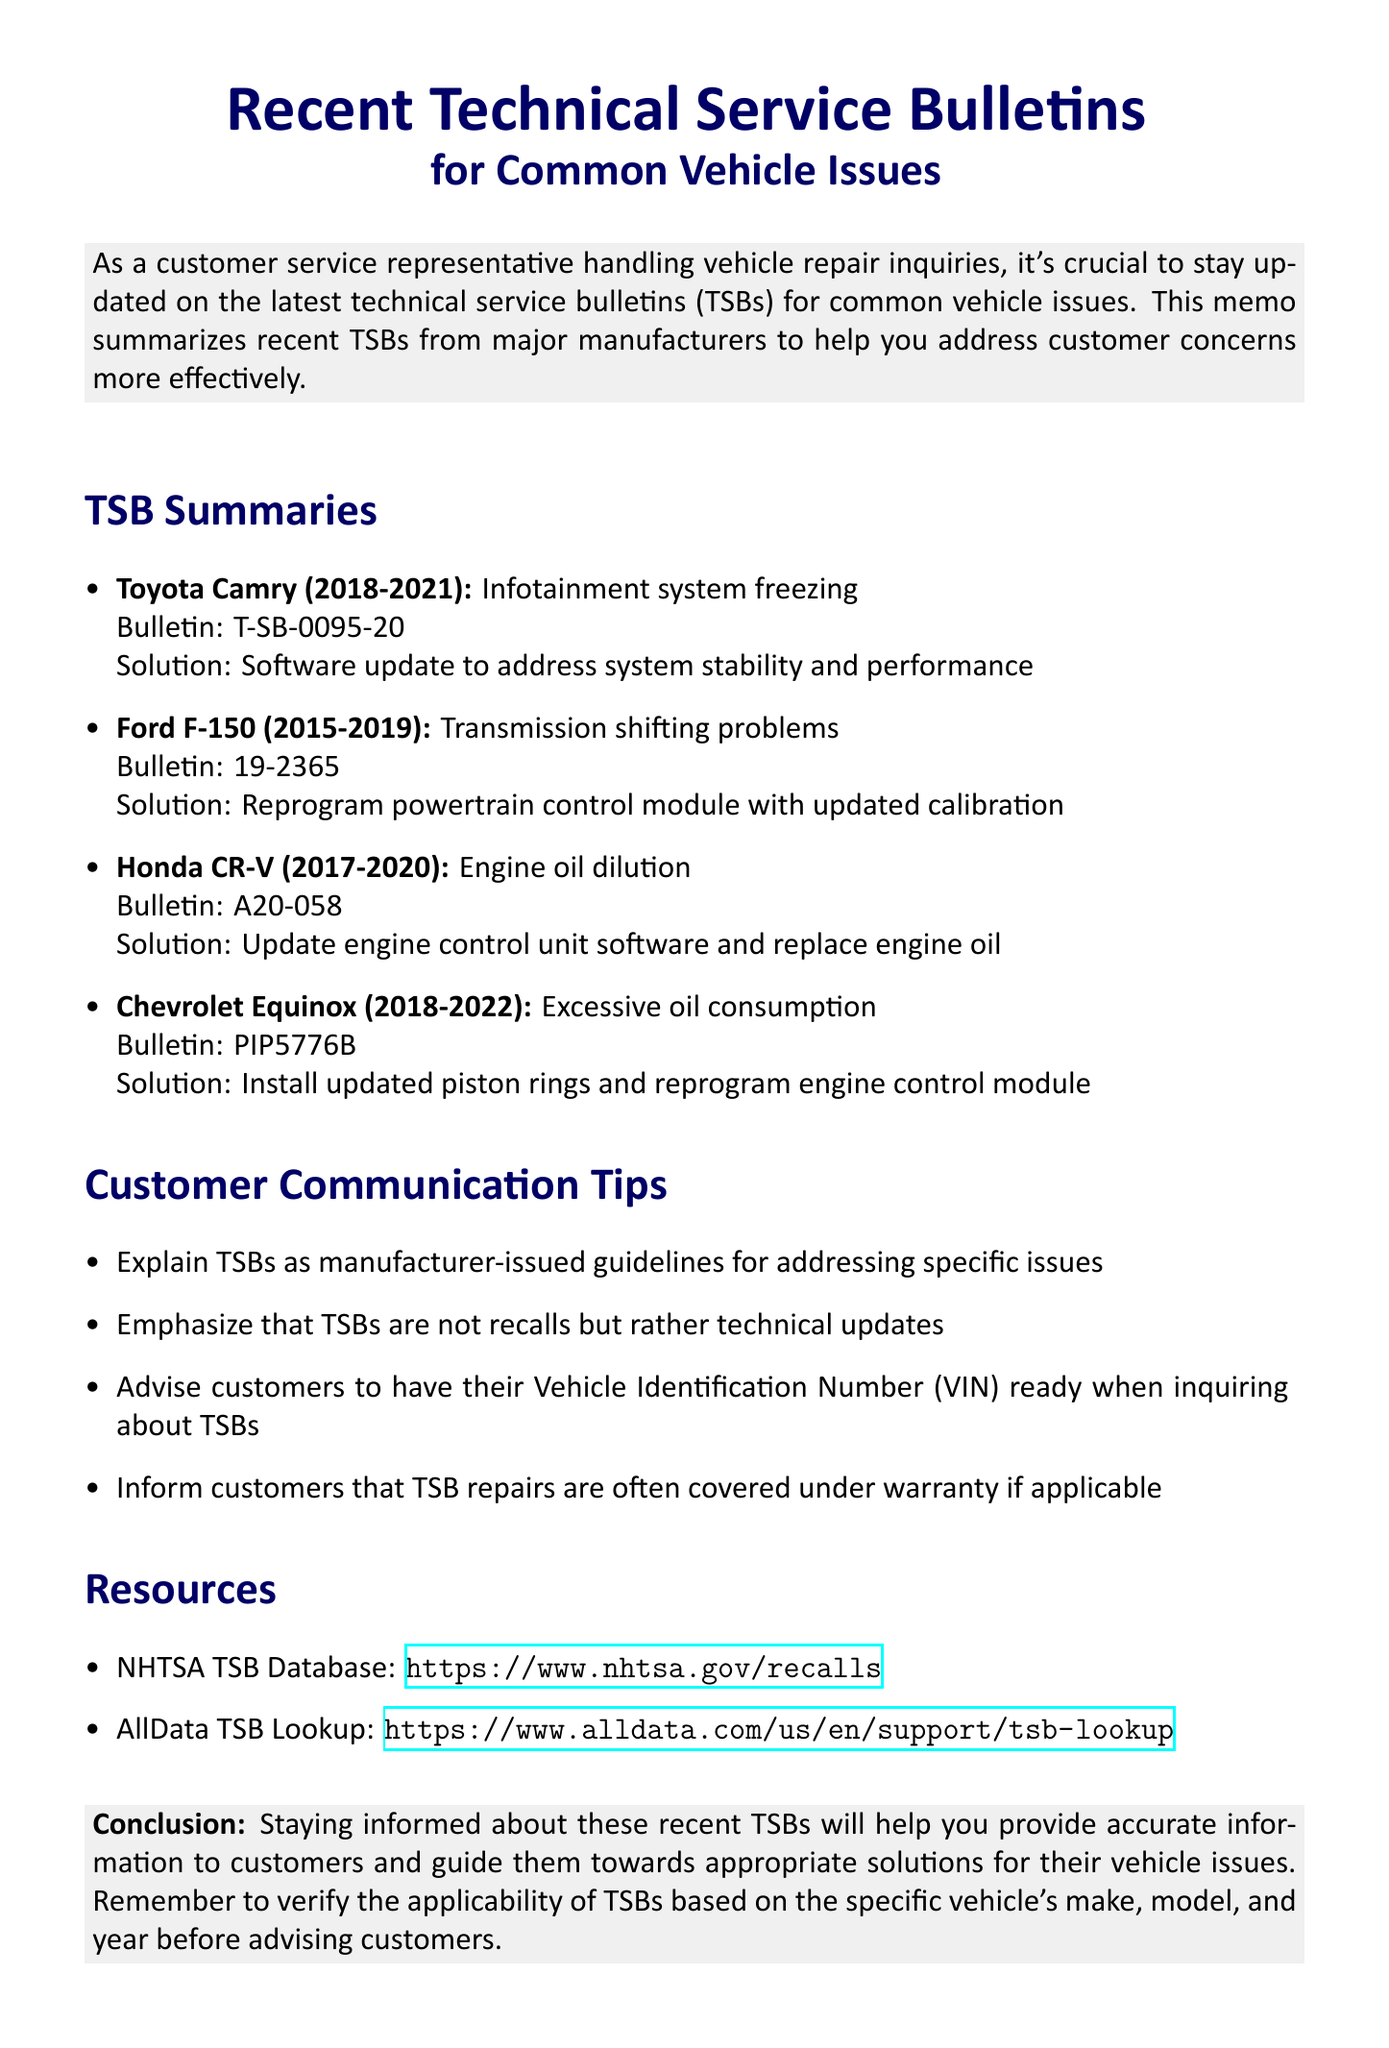What is the memo title? The title of the memo is provided at the beginning of the document, summarizing its focus.
Answer: Recent Technical Service Bulletins for Common Vehicle Issues What issue does the TSB for the Honda CR-V address? The document details specific issues associated with various vehicles, including the Honda CR-V, outlining multiple TSBs.
Answer: Engine oil dilution What is the solution for the Toyota Camry's infotainment system issue? The document summarizes each TSB and its corresponding solution, particularly for the highlighted vehicles.
Answer: Software update to address system stability and performance Which model is affected by bulletin number PIP5776B? The TSB summaries provide manufacturer and model information associated with each bulletin number, allowing identification of affected vehicles.
Answer: Chevrolet Equinox What years does the Ford F-150 TSB cover? The TSB summaries indicate a specified year range for each vehicle model, highlighting the applicability of the bulletins.
Answer: 2015-2019 Are TSB repairs often covered under warranty? The communication tips section addresses how to inform customers regarding TSBs and their coverage in warranty contexts.
Answer: Yes What is one resource provided for further TSB information? The resources section in the document lists websites where additional TSB information can be accessed.
Answer: NHTSA TSB Database What does TSB stand for? The memo includes the acronym TSB, referring to technical service bulletins, clearly defined within the context of vehicle repairs.
Answer: Technical Service Bulletins 